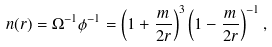<formula> <loc_0><loc_0><loc_500><loc_500>n ( r ) = \Omega ^ { - 1 } \phi ^ { - 1 } = \left ( 1 + \frac { m } { 2 r } \right ) ^ { 3 } \left ( 1 - \frac { m } { 2 r } \right ) ^ { - 1 } ,</formula> 